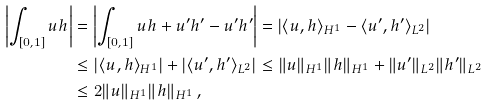<formula> <loc_0><loc_0><loc_500><loc_500>\left | \int _ { [ 0 , 1 ] } u h \right | & = \left | \int _ { [ 0 , 1 ] } u h + u ^ { \prime } h ^ { \prime } - u ^ { \prime } h ^ { \prime } \right | = \left | \langle u , h \rangle _ { H ^ { 1 } } - \langle u ^ { \prime } , h ^ { \prime } \rangle _ { L ^ { 2 } } \right | \\ & \leq \left | \langle u , h \rangle _ { H ^ { 1 } } \right | + \left | \langle u ^ { \prime } , h ^ { \prime } \rangle _ { L ^ { 2 } } \right | \leq \| u \| _ { H ^ { 1 } } \| h \| _ { H ^ { 1 } } + \| u ^ { \prime } \| _ { L ^ { 2 } } \| h ^ { \prime } \| _ { L ^ { 2 } } \\ & \leq 2 \| u \| _ { H ^ { 1 } } \| h \| _ { H ^ { 1 } } \, ,</formula> 